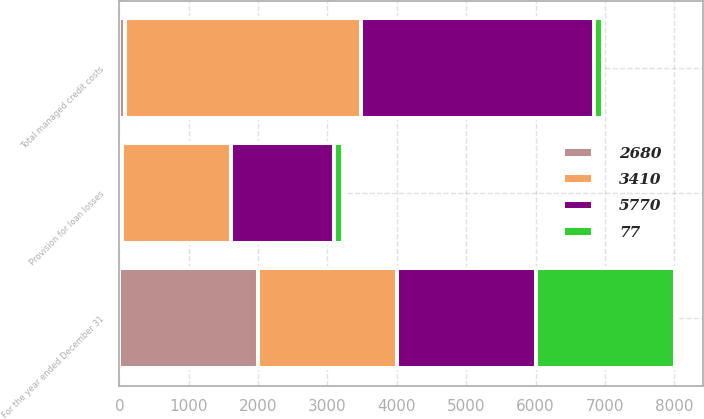Convert chart. <chart><loc_0><loc_0><loc_500><loc_500><stacked_bar_chart><ecel><fcel>For the year ended December 31<fcel>Provision for loan losses<fcel>Total managed credit costs<nl><fcel>2680<fcel>2003<fcel>30<fcel>77<nl><fcel>5770<fcel>2003<fcel>1491<fcel>3361<nl><fcel>77<fcel>2003<fcel>118<fcel>126<nl><fcel>3410<fcel>2003<fcel>1579<fcel>3410<nl></chart> 